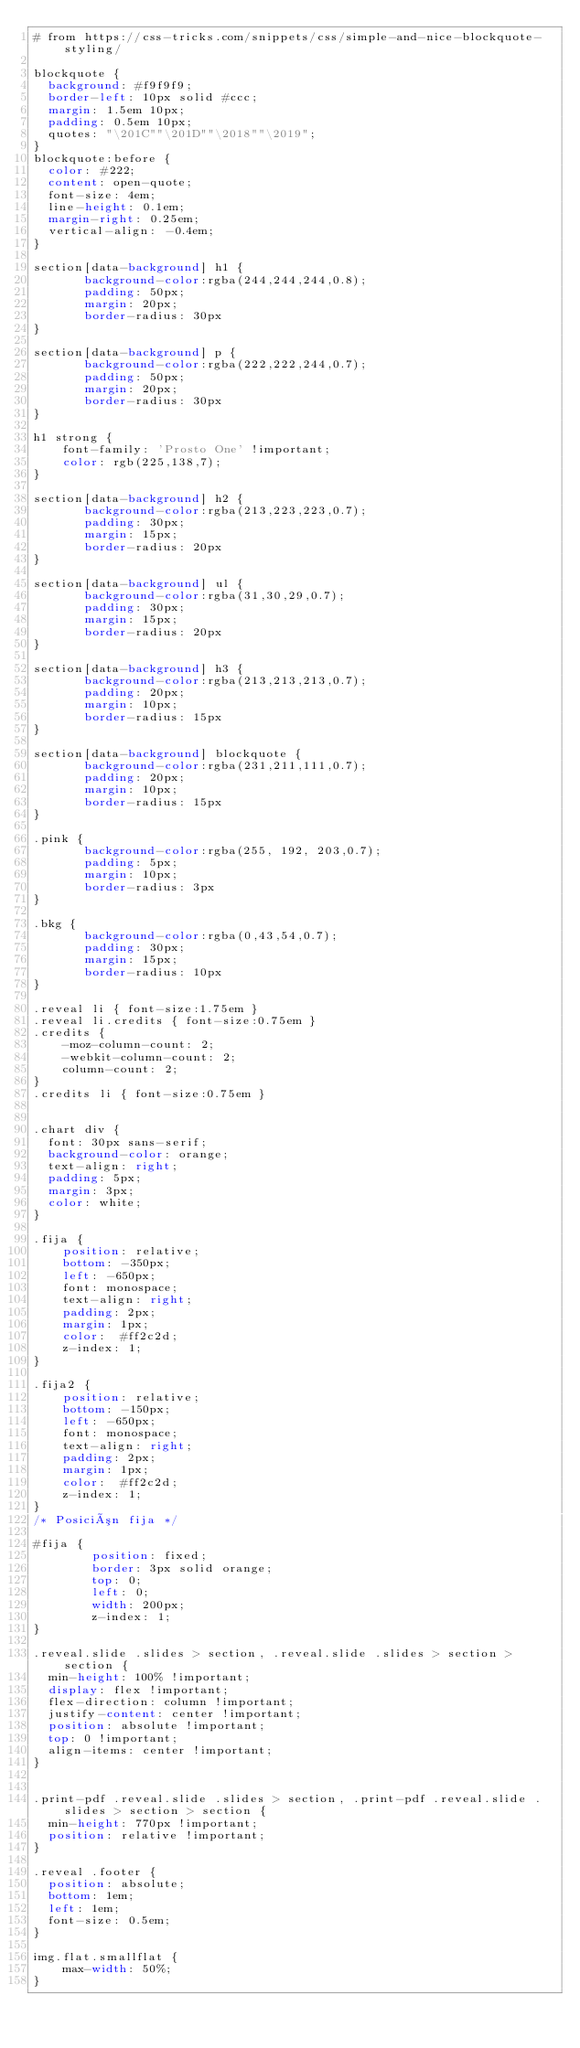Convert code to text. <code><loc_0><loc_0><loc_500><loc_500><_CSS_># from https://css-tricks.com/snippets/css/simple-and-nice-blockquote-styling/

blockquote {
  background: #f9f9f9;
  border-left: 10px solid #ccc;
  margin: 1.5em 10px;
  padding: 0.5em 10px;
  quotes: "\201C""\201D""\2018""\2019";
}
blockquote:before {
  color: #222;
  content: open-quote;
  font-size: 4em;
  line-height: 0.1em;
  margin-right: 0.25em;
  vertical-align: -0.4em;
}

section[data-background] h1 { 
       background-color:rgba(244,244,244,0.8);
       padding: 50px;
       margin: 20px;
       border-radius: 30px
}

section[data-background] p { 
       background-color:rgba(222,222,244,0.7);
       padding: 50px;
       margin: 20px;
       border-radius: 30px
}

h1 strong {
    font-family: 'Prosto One' !important;
    color: rgb(225,138,7);
}

section[data-background] h2 {
       background-color:rgba(213,223,223,0.7);
       padding: 30px;
       margin: 15px;
       border-radius: 20px
}

section[data-background] ul {
       background-color:rgba(31,30,29,0.7);
       padding: 30px;
       margin: 15px;
       border-radius: 20px
}

section[data-background] h3 {
       background-color:rgba(213,213,213,0.7);
       padding: 20px;
       margin: 10px;
       border-radius: 15px
}

section[data-background] blockquote {
       background-color:rgba(231,211,111,0.7);
       padding: 20px;
       margin: 10px;
       border-radius: 15px
}

.pink { 
       background-color:rgba(255, 192, 203,0.7);
       padding: 5px;
       margin: 10px;
       border-radius: 3px
}

.bkg { 
       background-color:rgba(0,43,54,0.7);
       padding: 30px;
       margin: 15px;
       border-radius: 10px
}

.reveal li { font-size:1.75em }
.reveal li.credits { font-size:0.75em }
.credits {
    -moz-column-count: 2;
    -webkit-column-count: 2;
    column-count: 2;
}
.credits li { font-size:0.75em }


.chart div {
  font: 30px sans-serif;
  background-color: orange;
  text-align: right;
  padding: 5px;
  margin: 3px;
  color: white;
}

.fija {
    position: relative;
    bottom: -350px;
    left: -650px;
    font: monospace;
    text-align: right;
    padding: 2px;
    margin: 1px;
    color:  #ff2c2d;
    z-index: 1;           
}

.fija2 {
    position: relative;
    bottom: -150px;
    left: -650px;
    font: monospace;
    text-align: right;
    padding: 2px;
    margin: 1px;
    color:  #ff2c2d;
    z-index: 1;           
}
/* Posición fija */

#fija { 
        position: fixed;
        border: 3px solid orange;
        top: 0;
        left: 0;
        width: 200px;
        z-index: 1;           
}

.reveal.slide .slides > section, .reveal.slide .slides > section > section {
  min-height: 100% !important;
  display: flex !important;
  flex-direction: column !important;
  justify-content: center !important;
  position: absolute !important;
  top: 0 !important;
  align-items: center !important;
}


.print-pdf .reveal.slide .slides > section, .print-pdf .reveal.slide .slides > section > section {
  min-height: 770px !important;
  position: relative !important;
}

.reveal .footer {
  position: absolute;
  bottom: 1em;
  left: 1em;
  font-size: 0.5em;
}

img.flat.smallflat {
    max-width: 50%;
}


</code> 